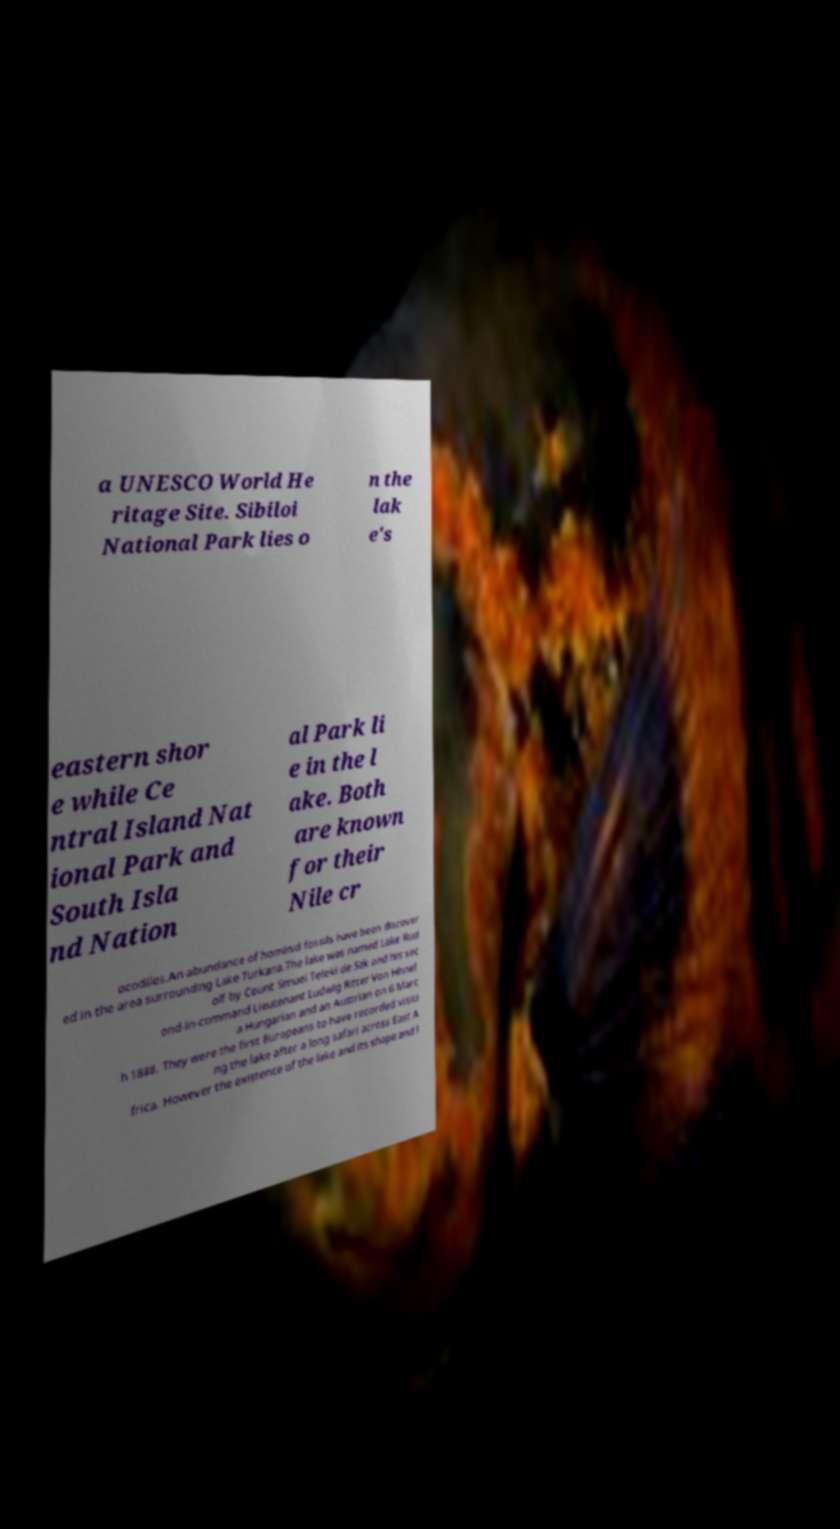Could you assist in decoding the text presented in this image and type it out clearly? a UNESCO World He ritage Site. Sibiloi National Park lies o n the lak e's eastern shor e while Ce ntral Island Nat ional Park and South Isla nd Nation al Park li e in the l ake. Both are known for their Nile cr ocodiles.An abundance of hominid fossils have been discover ed in the area surrounding Lake Turkana.The lake was named Lake Rud olf by Count Smuel Teleki de Szk and his sec ond-in-command Lieutenant Ludwig Ritter Von Hhnel a Hungarian and an Austrian on 6 Marc h 1888. They were the first Europeans to have recorded visiti ng the lake after a long safari across East A frica. However the existence of the lake and its shape and l 